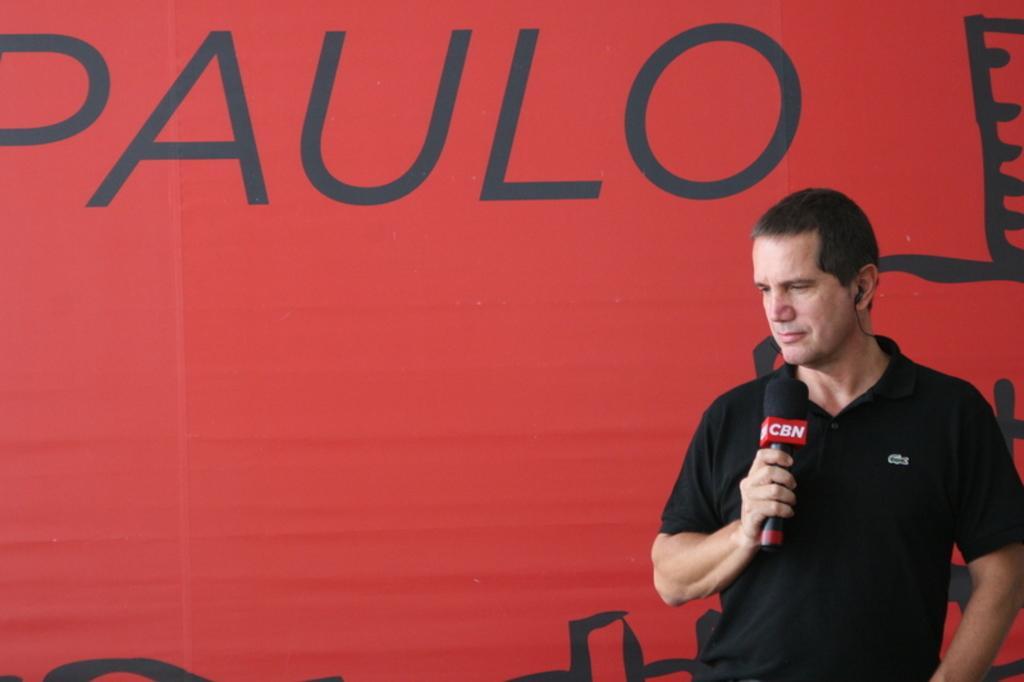Could you give a brief overview of what you see in this image? In this image I can see the person with the black color dress and holding the mic. I can see the red color background and something is written. 